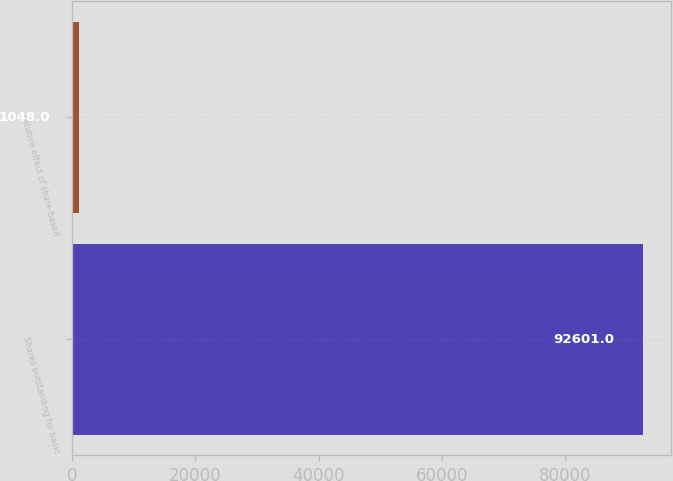<chart> <loc_0><loc_0><loc_500><loc_500><bar_chart><fcel>Shares outstanding for basic<fcel>Dilutive effect of share-based<nl><fcel>92601<fcel>1048<nl></chart> 